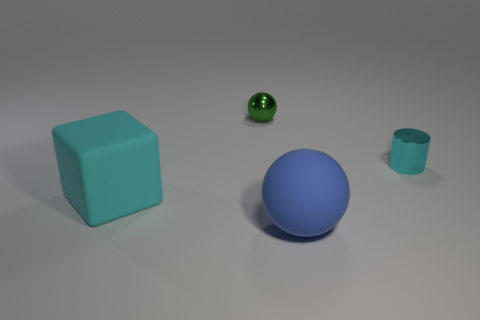If these objects were part of a game, what rules could be involved? If these were part of a game, perhaps the large spheres could be the 'players' that need to navigate around the 'obstacles', which could be the block and the cylinder. The goal might be to maneuver without touching these obstacles, and points could be scored based on the path taken or the time completed. The small sphere could serve as a 'bonus' object to collect for extra points. 